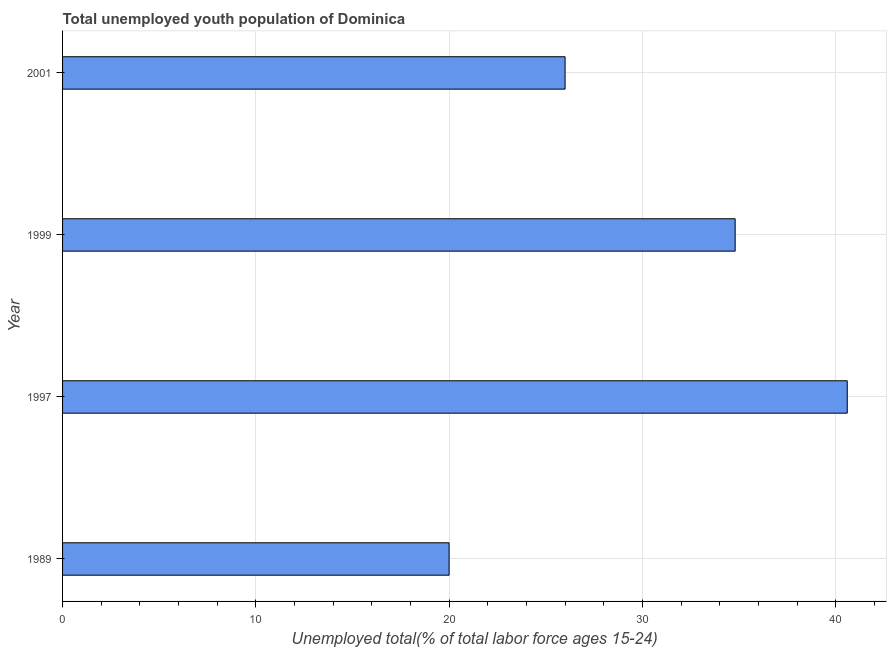Does the graph contain grids?
Your answer should be compact. Yes. What is the title of the graph?
Give a very brief answer. Total unemployed youth population of Dominica. What is the label or title of the X-axis?
Keep it short and to the point. Unemployed total(% of total labor force ages 15-24). What is the unemployed youth in 1997?
Give a very brief answer. 40.6. Across all years, what is the maximum unemployed youth?
Your response must be concise. 40.6. Across all years, what is the minimum unemployed youth?
Make the answer very short. 20. In which year was the unemployed youth maximum?
Offer a very short reply. 1997. What is the sum of the unemployed youth?
Ensure brevity in your answer.  121.4. What is the average unemployed youth per year?
Make the answer very short. 30.35. What is the median unemployed youth?
Provide a succinct answer. 30.4. Do a majority of the years between 1999 and 2001 (inclusive) have unemployed youth greater than 22 %?
Offer a very short reply. Yes. What is the ratio of the unemployed youth in 1997 to that in 1999?
Offer a very short reply. 1.17. Is the unemployed youth in 1989 less than that in 1997?
Offer a terse response. Yes. Is the sum of the unemployed youth in 1997 and 1999 greater than the maximum unemployed youth across all years?
Offer a terse response. Yes. What is the difference between the highest and the lowest unemployed youth?
Ensure brevity in your answer.  20.6. How many bars are there?
Offer a terse response. 4. Are all the bars in the graph horizontal?
Offer a terse response. Yes. What is the Unemployed total(% of total labor force ages 15-24) in 1989?
Your answer should be compact. 20. What is the Unemployed total(% of total labor force ages 15-24) of 1997?
Your response must be concise. 40.6. What is the Unemployed total(% of total labor force ages 15-24) of 1999?
Your response must be concise. 34.8. What is the Unemployed total(% of total labor force ages 15-24) in 2001?
Provide a succinct answer. 26. What is the difference between the Unemployed total(% of total labor force ages 15-24) in 1989 and 1997?
Offer a very short reply. -20.6. What is the difference between the Unemployed total(% of total labor force ages 15-24) in 1989 and 1999?
Keep it short and to the point. -14.8. What is the difference between the Unemployed total(% of total labor force ages 15-24) in 1989 and 2001?
Your answer should be very brief. -6. What is the difference between the Unemployed total(% of total labor force ages 15-24) in 1997 and 1999?
Provide a succinct answer. 5.8. What is the difference between the Unemployed total(% of total labor force ages 15-24) in 1999 and 2001?
Make the answer very short. 8.8. What is the ratio of the Unemployed total(% of total labor force ages 15-24) in 1989 to that in 1997?
Keep it short and to the point. 0.49. What is the ratio of the Unemployed total(% of total labor force ages 15-24) in 1989 to that in 1999?
Offer a very short reply. 0.57. What is the ratio of the Unemployed total(% of total labor force ages 15-24) in 1989 to that in 2001?
Make the answer very short. 0.77. What is the ratio of the Unemployed total(% of total labor force ages 15-24) in 1997 to that in 1999?
Your response must be concise. 1.17. What is the ratio of the Unemployed total(% of total labor force ages 15-24) in 1997 to that in 2001?
Your response must be concise. 1.56. What is the ratio of the Unemployed total(% of total labor force ages 15-24) in 1999 to that in 2001?
Your response must be concise. 1.34. 